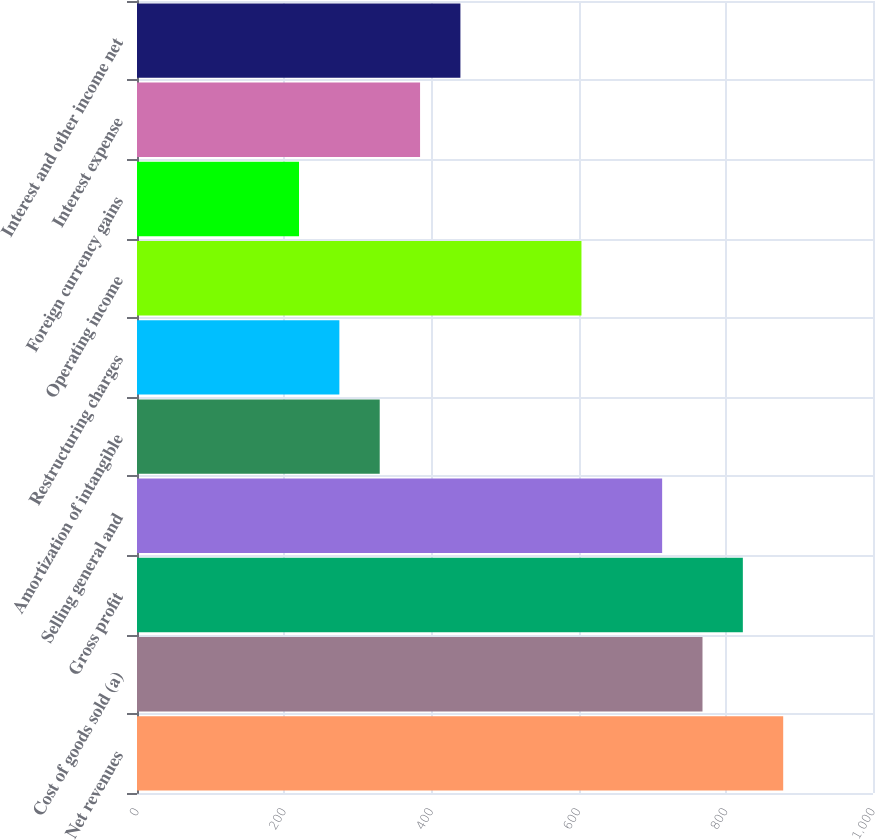Convert chart. <chart><loc_0><loc_0><loc_500><loc_500><bar_chart><fcel>Net revenues<fcel>Cost of goods sold (a)<fcel>Gross profit<fcel>Selling general and<fcel>Amortization of intangible<fcel>Restructuring charges<fcel>Operating income<fcel>Foreign currency gains<fcel>Interest expense<fcel>Interest and other income net<nl><fcel>877.98<fcel>768.34<fcel>823.16<fcel>713.52<fcel>329.78<fcel>274.96<fcel>603.88<fcel>220.14<fcel>384.6<fcel>439.42<nl></chart> 